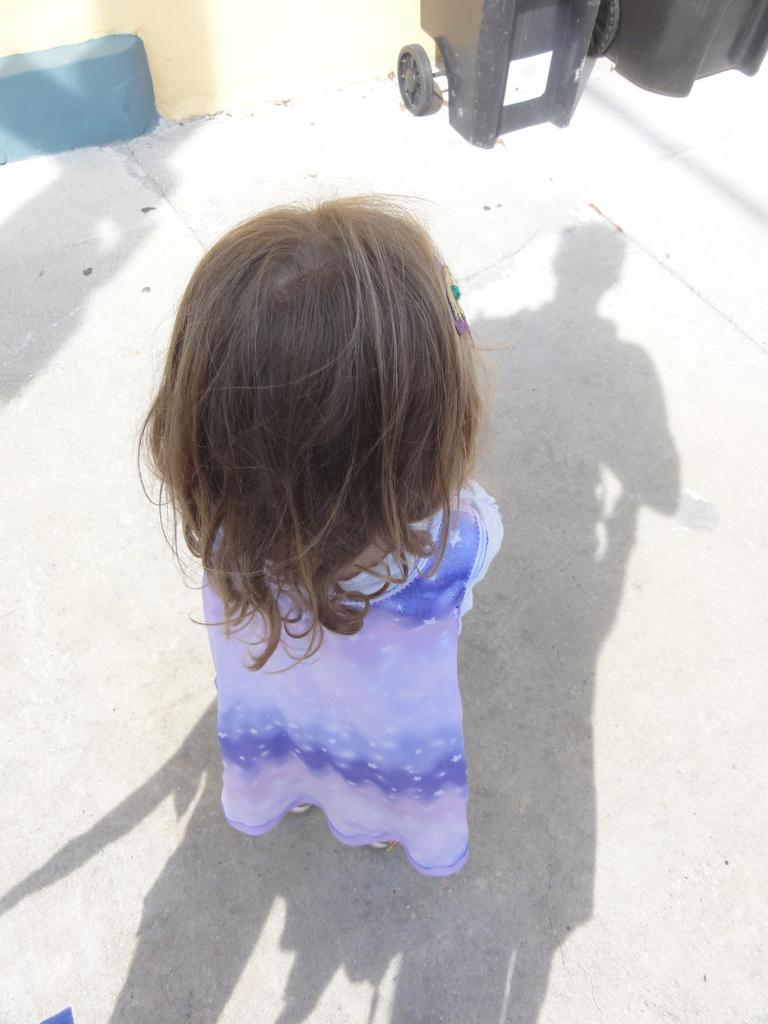What is the main subject of the image? There is a person standing in the center of the image. What can be seen on the ground in the image? There is a shadow on the ground. What color are the objects at the top of the image? The objects at the top of the image are black. What type of structure is visible in the image? There is a wall visible in the image. Reasoning: Let' Let's think step by step in order to produce the conversation. We start by identifying the main subject of the image, which is the person standing in the center. Then, we describe the shadow on the ground and the black objects at the top of the image. Finally, we mention the presence of a wall in the image. Each question is designed to elicit a specific detail about the image that is known from the provided facts. Absurd Question/Answer: What type of fang can be seen in the image? There is no fang present in the image. What texture is visible on the wall in the image? The provided facts do not mention the texture of the wall, so we cannot determine its texture from the information given. What type of fang can be seen in the image? There is no fang present in the image. What texture is visible on the wall in the image? The provided facts do not mention the texture of the wall, so we cannot determine its texture from the information given. 